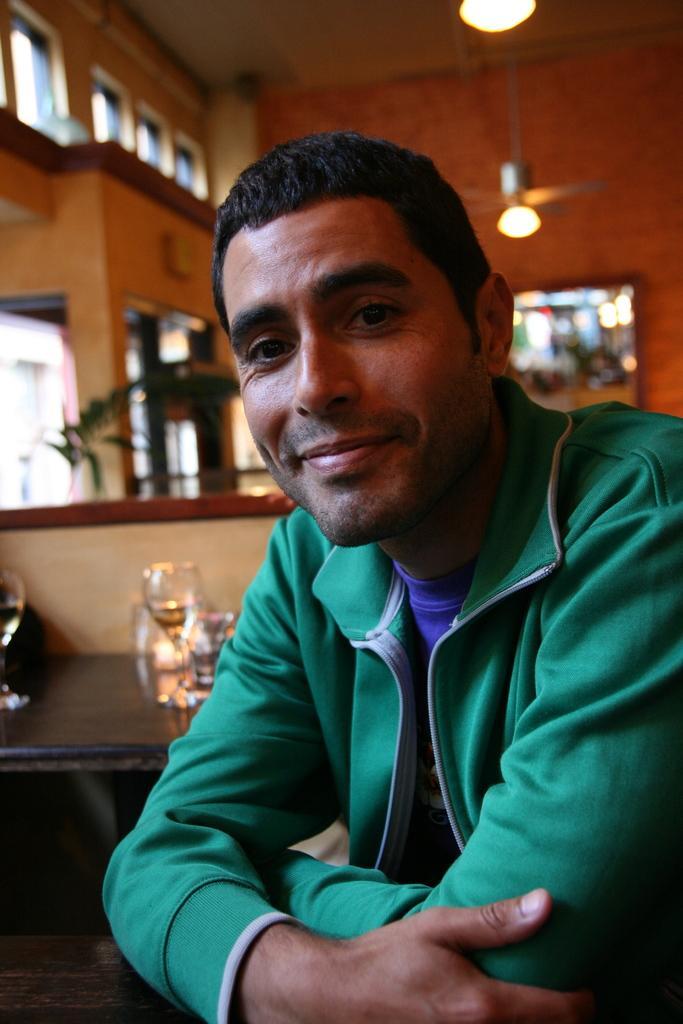Can you describe this image briefly? In the image there is a man, he is wearing green jacket and the background of the man is blur. 